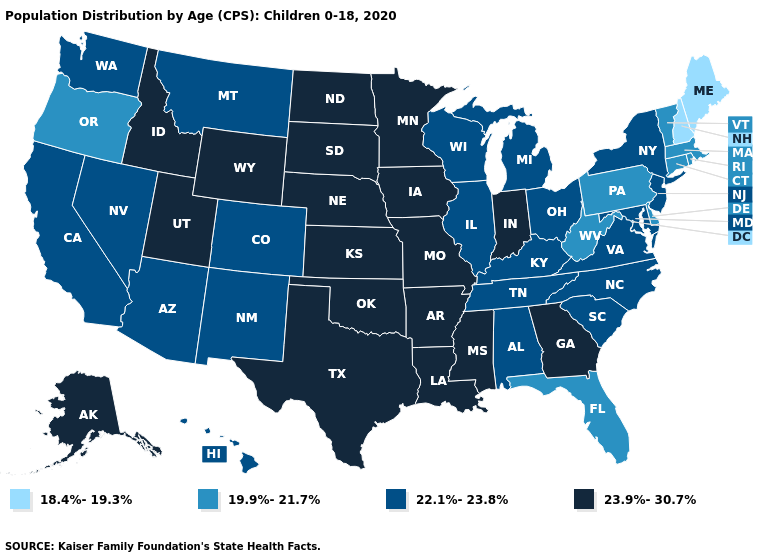Name the states that have a value in the range 22.1%-23.8%?
Give a very brief answer. Alabama, Arizona, California, Colorado, Hawaii, Illinois, Kentucky, Maryland, Michigan, Montana, Nevada, New Jersey, New Mexico, New York, North Carolina, Ohio, South Carolina, Tennessee, Virginia, Washington, Wisconsin. What is the value of Utah?
Quick response, please. 23.9%-30.7%. What is the value of Oklahoma?
Answer briefly. 23.9%-30.7%. What is the highest value in the Northeast ?
Write a very short answer. 22.1%-23.8%. Does Mississippi have the lowest value in the South?
Short answer required. No. Name the states that have a value in the range 19.9%-21.7%?
Quick response, please. Connecticut, Delaware, Florida, Massachusetts, Oregon, Pennsylvania, Rhode Island, Vermont, West Virginia. What is the lowest value in states that border North Dakota?
Keep it brief. 22.1%-23.8%. Name the states that have a value in the range 18.4%-19.3%?
Keep it brief. Maine, New Hampshire. Which states have the highest value in the USA?
Write a very short answer. Alaska, Arkansas, Georgia, Idaho, Indiana, Iowa, Kansas, Louisiana, Minnesota, Mississippi, Missouri, Nebraska, North Dakota, Oklahoma, South Dakota, Texas, Utah, Wyoming. What is the value of Oklahoma?
Write a very short answer. 23.9%-30.7%. Among the states that border Florida , does Georgia have the highest value?
Short answer required. Yes. Which states have the lowest value in the MidWest?
Write a very short answer. Illinois, Michigan, Ohio, Wisconsin. Name the states that have a value in the range 23.9%-30.7%?
Be succinct. Alaska, Arkansas, Georgia, Idaho, Indiana, Iowa, Kansas, Louisiana, Minnesota, Mississippi, Missouri, Nebraska, North Dakota, Oklahoma, South Dakota, Texas, Utah, Wyoming. What is the highest value in states that border North Dakota?
Be succinct. 23.9%-30.7%. Among the states that border California , which have the lowest value?
Be succinct. Oregon. 